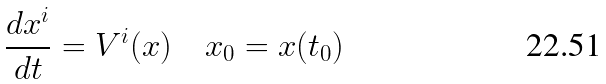<formula> <loc_0><loc_0><loc_500><loc_500>\frac { d x ^ { i } } { d t } = V ^ { i } ( x ) \quad x _ { 0 } = x ( t _ { 0 } )</formula> 